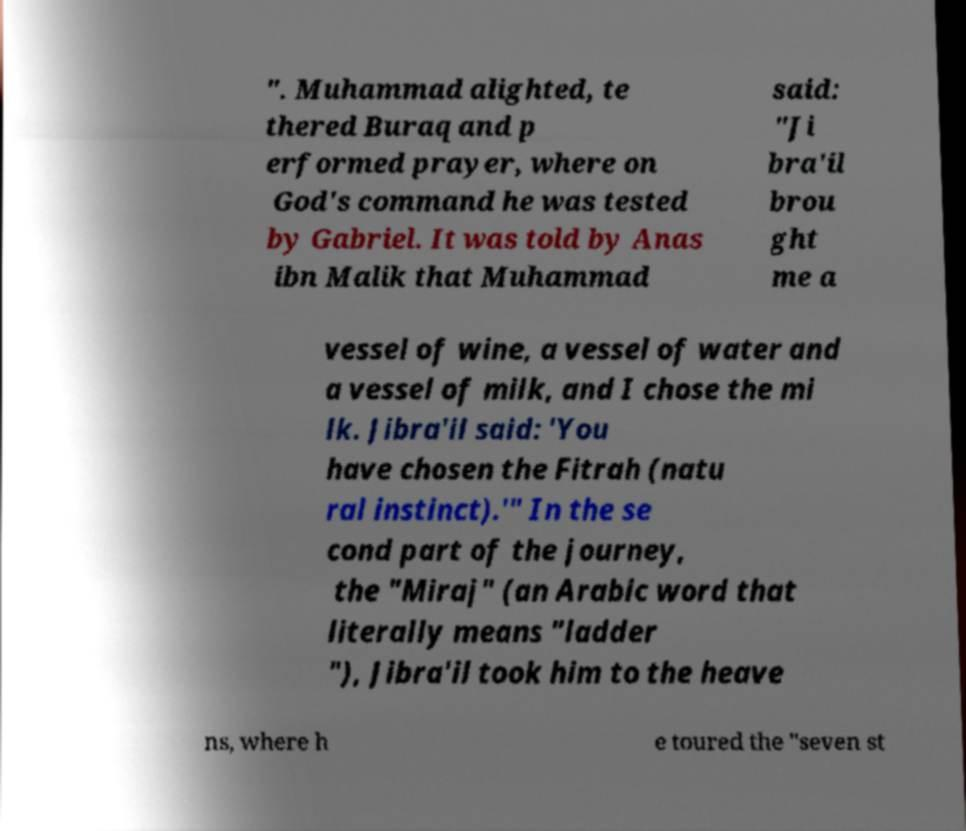Can you accurately transcribe the text from the provided image for me? ". Muhammad alighted, te thered Buraq and p erformed prayer, where on God's command he was tested by Gabriel. It was told by Anas ibn Malik that Muhammad said: "Ji bra'il brou ght me a vessel of wine, a vessel of water and a vessel of milk, and I chose the mi lk. Jibra'il said: 'You have chosen the Fitrah (natu ral instinct).'" In the se cond part of the journey, the "Miraj" (an Arabic word that literally means "ladder "), Jibra'il took him to the heave ns, where h e toured the "seven st 